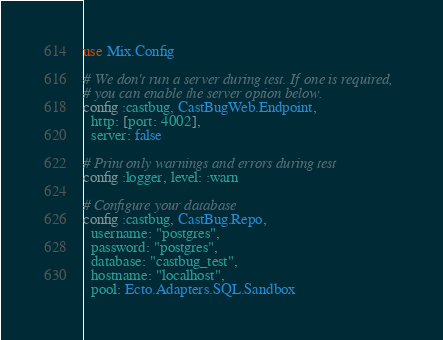<code> <loc_0><loc_0><loc_500><loc_500><_Elixir_>use Mix.Config

# We don't run a server during test. If one is required,
# you can enable the server option below.
config :castbug, CastBugWeb.Endpoint,
  http: [port: 4002],
  server: false

# Print only warnings and errors during test
config :logger, level: :warn

# Configure your database
config :castbug, CastBug.Repo,
  username: "postgres",
  password: "postgres",
  database: "castbug_test",
  hostname: "localhost",
  pool: Ecto.Adapters.SQL.Sandbox
</code> 